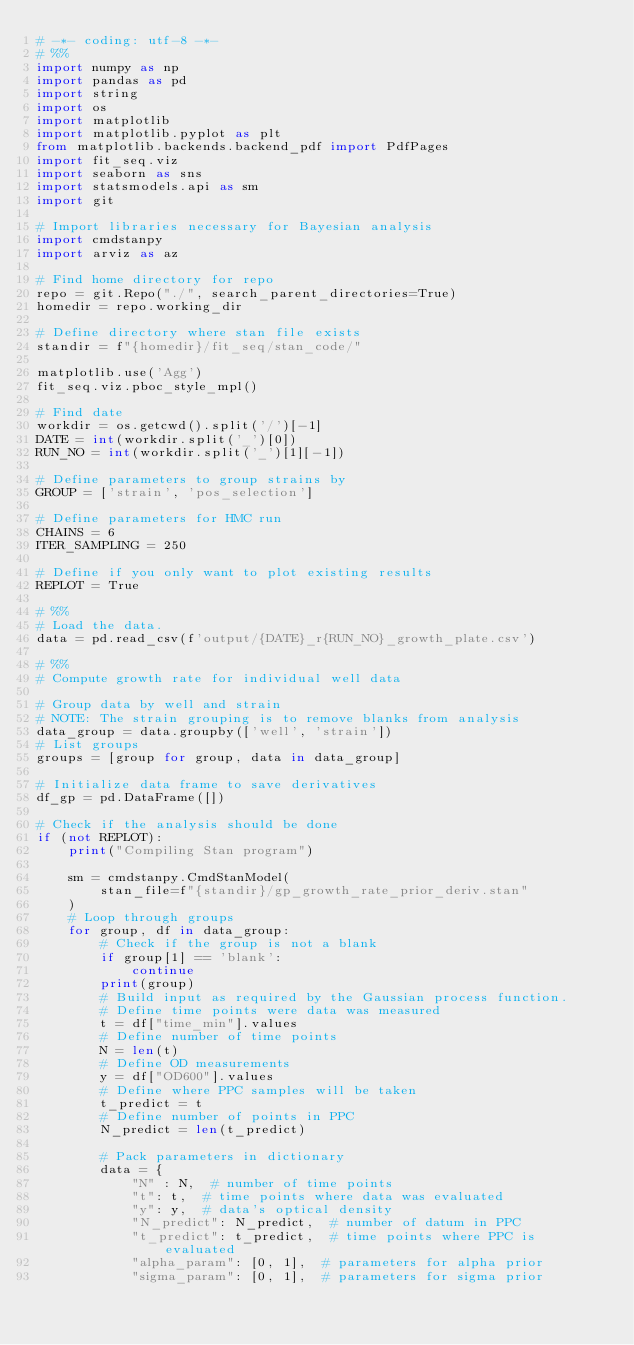<code> <loc_0><loc_0><loc_500><loc_500><_Python_># -*- coding: utf-8 -*-
# %%
import numpy as np
import pandas as pd
import string
import os
import matplotlib
import matplotlib.pyplot as plt
from matplotlib.backends.backend_pdf import PdfPages
import fit_seq.viz
import seaborn as sns
import statsmodels.api as sm
import git

# Import libraries necessary for Bayesian analysis
import cmdstanpy
import arviz as az

# Find home directory for repo
repo = git.Repo("./", search_parent_directories=True)
homedir = repo.working_dir

# Define directory where stan file exists
standir = f"{homedir}/fit_seq/stan_code/"

matplotlib.use('Agg')
fit_seq.viz.pboc_style_mpl()

# Find date
workdir = os.getcwd().split('/')[-1]
DATE = int(workdir.split('_')[0])
RUN_NO = int(workdir.split('_')[1][-1])

# Define parameters to group strains by
GROUP = ['strain', 'pos_selection']

# Define parameters for HMC run
CHAINS = 6
ITER_SAMPLING = 250

# Define if you only want to plot existing results
REPLOT = True

# %%
# Load the data.
data = pd.read_csv(f'output/{DATE}_r{RUN_NO}_growth_plate.csv')

# %%
# Compute growth rate for individual well data

# Group data by well and strain
# NOTE: The strain grouping is to remove blanks from analysis
data_group = data.groupby(['well', 'strain'])
# List groups
groups = [group for group, data in data_group]

# Initialize data frame to save derivatives
df_gp = pd.DataFrame([])

# Check if the analysis should be done
if (not REPLOT):
    print("Compiling Stan program")

    sm = cmdstanpy.CmdStanModel(
        stan_file=f"{standir}/gp_growth_rate_prior_deriv.stan"
    )
    # Loop through groups
    for group, df in data_group:
        # Check if the group is not a blank
        if group[1] == 'blank':
            continue
        print(group)
        # Build input as required by the Gaussian process function.
        # Define time points were data was measured
        t = df["time_min"].values
        # Define number of time points
        N = len(t)
        # Define OD measurements
        y = df["OD600"].values
        # Define where PPC samples will be taken
        t_predict = t
        # Define number of points in PPC
        N_predict = len(t_predict)

        # Pack parameters in dictionary
        data = {
            "N" : N,  # number of time points
            "t": t,  # time points where data was evaluated
            "y": y,  # data's optical density
            "N_predict": N_predict,  # number of datum in PPC
            "t_predict": t_predict,  # time points where PPC is evaluated
            "alpha_param": [0, 1],  # parameters for alpha prior
            "sigma_param": [0, 1],  # parameters for sigma prior</code> 